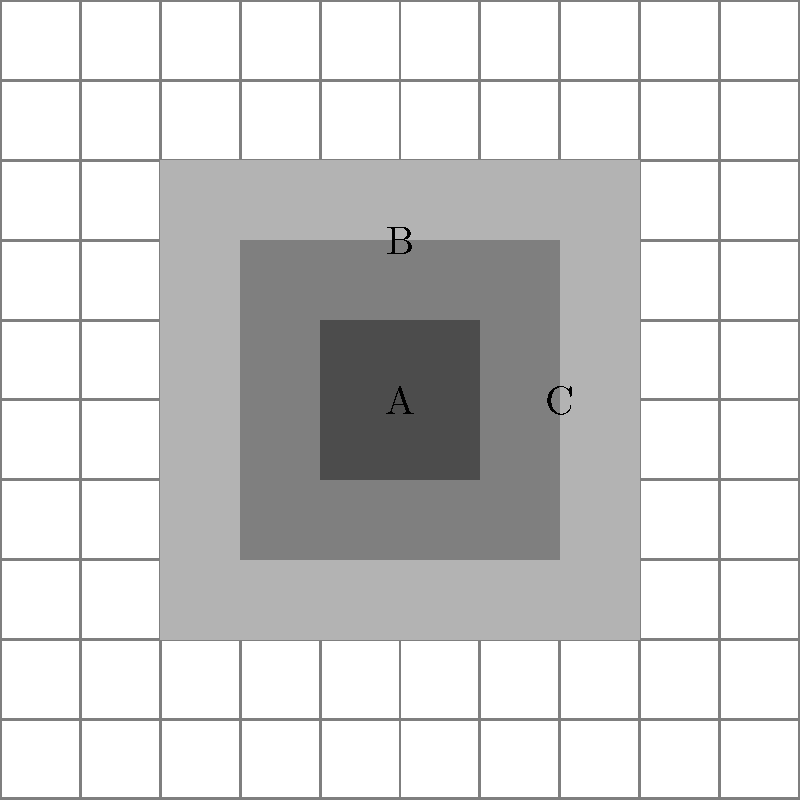As a community organizer planning a protest, you're estimating crowd sizes using satellite imagery. The image above shows a grid overlay of the protest area, where each grid square represents 100 square meters. The shaded areas A, B, and C represent different crowd densities:

A: 4 people per square meter
B: 2 people per square meter
C: 1 person per square meter

If the total protest area covers 60 grid squares, with area A covering 4 squares, area B covering 16 squares, and area C covering 20 squares, what is the estimated total number of protesters? Let's break this down step-by-step:

1. Calculate the area of each density zone:
   A: 4 squares × 100 m² = 400 m²
   B: 16 squares × 100 m² = 1,600 m²
   C: 20 squares × 100 m² = 2,000 m²

2. Calculate the number of people in each zone:
   A: 400 m² × 4 people/m² = 1,600 people
   B: 1,600 m² × 2 people/m² = 3,200 people
   C: 2,000 m² × 1 person/m² = 2,000 people

3. Sum up the total number of protesters:
   Total = 1,600 + 3,200 + 2,000 = 6,800 people

4. Check: 
   Total squares used = 4 + 16 + 20 = 40 squares
   Remaining area = 60 - 40 = 20 squares (assumed to be empty)

Therefore, the estimated total number of protesters is 6,800.
Answer: 6,800 protesters 